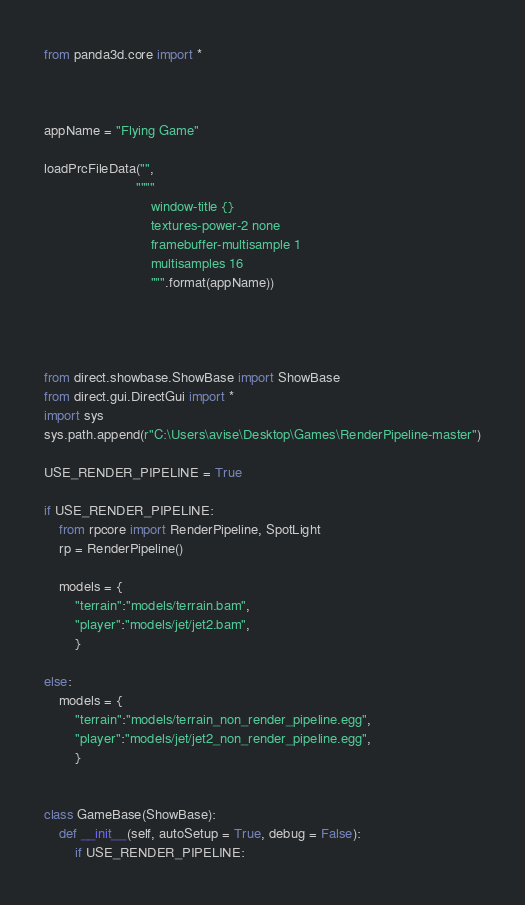<code> <loc_0><loc_0><loc_500><loc_500><_Python_>from panda3d.core import *



appName = "Flying Game"

loadPrcFileData("",
                        """"
                            window-title {}
                            textures-power-2 none
                            framebuffer-multisample 1
                            multisamples 16
                            """.format(appName))




from direct.showbase.ShowBase import ShowBase
from direct.gui.DirectGui import *
import sys
sys.path.append(r"C:\Users\avise\Desktop\Games\RenderPipeline-master")

USE_RENDER_PIPELINE = True

if USE_RENDER_PIPELINE:
    from rpcore import RenderPipeline, SpotLight
    rp = RenderPipeline()

    models = {
        "terrain":"models/terrain.bam",
        "player":"models/jet/jet2.bam",
        }

else:
    models = {
        "terrain":"models/terrain_non_render_pipeline.egg",
        "player":"models/jet/jet2_non_render_pipeline.egg",
        }
    

class GameBase(ShowBase):
    def __init__(self, autoSetup = True, debug = False):
        if USE_RENDER_PIPELINE:</code> 